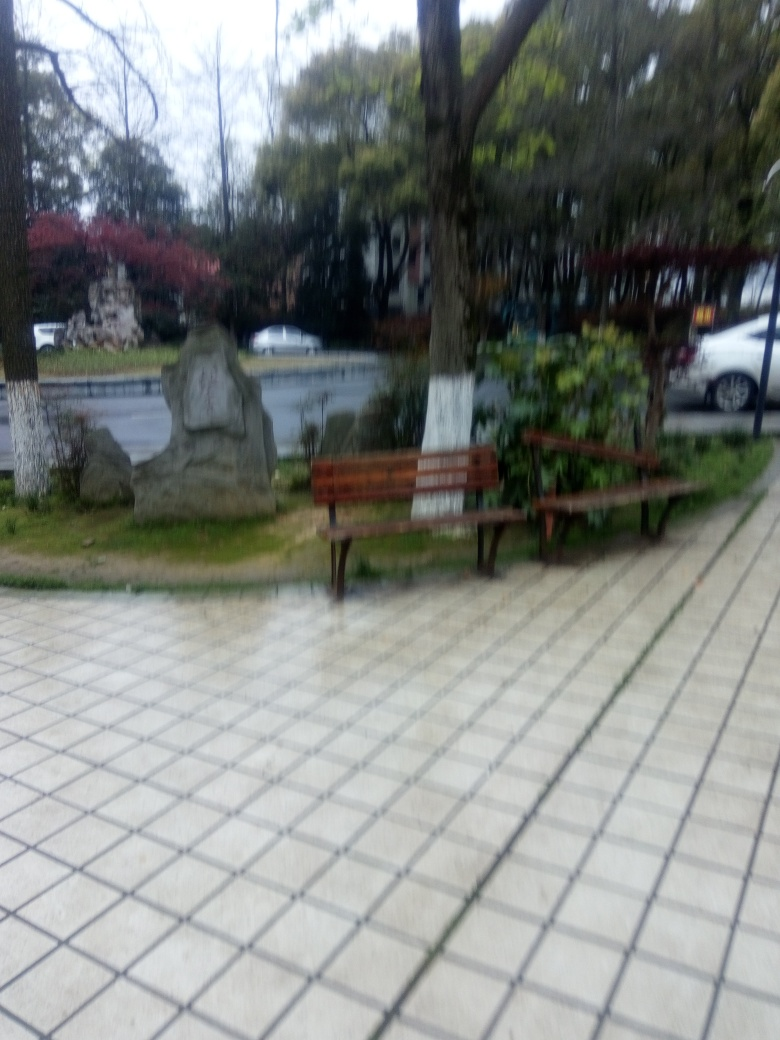What is the park bench made of? The park bench looks to be made of wooden slats for seating and backrest, with metal or possibly cast iron for the supports and armrests. Such materials are commonly used in outdoor furniture for their durability and aesthetic fit with natural surroundings. 